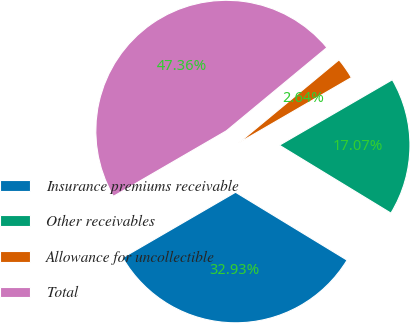Convert chart to OTSL. <chart><loc_0><loc_0><loc_500><loc_500><pie_chart><fcel>Insurance premiums receivable<fcel>Other receivables<fcel>Allowance for uncollectible<fcel>Total<nl><fcel>32.93%<fcel>17.07%<fcel>2.64%<fcel>47.36%<nl></chart> 